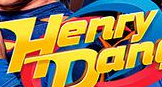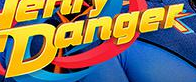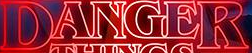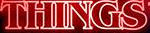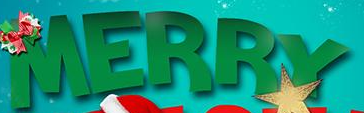Identify the words shown in these images in order, separated by a semicolon. Henry; Danger; DANGER; THINGS; MERRY 